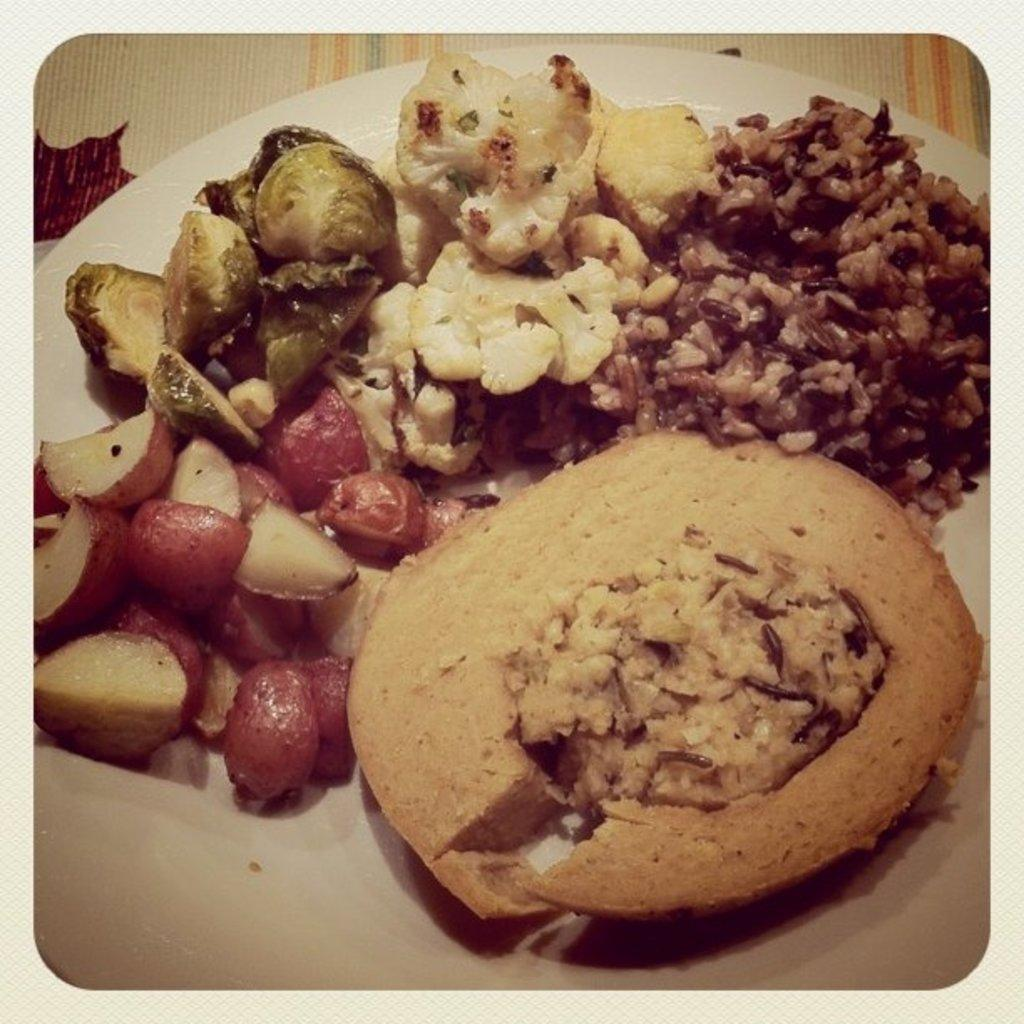What is placed on the plate in the image? There are food items placed on a plate in the image. What type of book can be seen on the plate in the image? There is no book present on the plate in the image; it contains food items. 